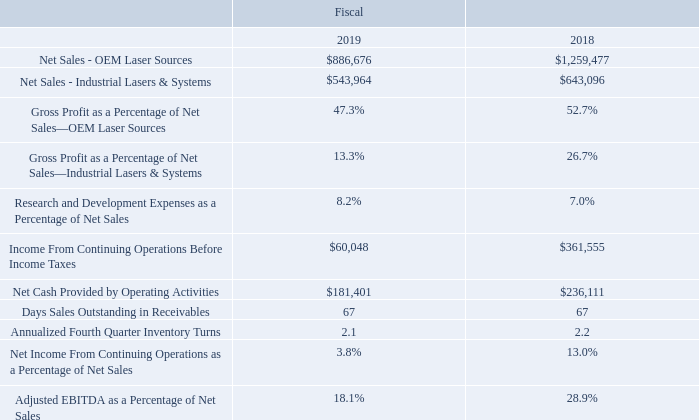KEY PERFORMANCE INDICATORS
Below is a summary of some of the quantitative performance indicators (as defined below) that are evaluated by management to assess our financial performance. Some of the indicators are non-GAAP measures and should not be considered as an alternative to any other measure for determining operating performance or liquidity that is calculated in accordance with generally accepted accounting principles.
Definitions and analysis of these performance indicators are as follows:
Net Sales Net sales include sales of lasers, laser systems, related accessories and service. Net sales for fiscal 2019 decreased 29.6% in our OLS segment and decreased 15.4% in our ILS segment from fiscal 2018. For a description of the reasons for changes in net sales refer to the ‘‘Results of Operations’’ section below.
Gross Profit as a Percentage of Net Sales Gross profit as a percentage of net sales (‘‘gross profit percentage’’) is calculated as gross profit for the period divided by net sales for the period. Gross profit percentage for OLS decreased to 47.3% in fiscal 2019 from 52.7% in fiscal 2018. Gross profit percentage for ILS decreased to 13.3% in fiscal 2019 from 26.7% in fiscal 2018. For a description of the reasons for changes in gross profit refer to the ‘‘Results of Operations’’ section below.
Research and Development as a Percentage of Net Sales Research and development as a percentage of net sales (‘‘R&D percentage’’) is calculated as research and development expense for the period divided by net sales for the period. Management considers R&D percentage to be an important indicator in managing our business as investing in new technologies is a key to future growth. R&D percentage increased to 8.2% in fiscal 2019 from 7.0% in fiscal 2018. For a description of the reasons for changes in R&D spending refer to the ‘‘Results of Operations’’ section below.
Net Cash Provided by Operating Activities Net cash provided by operating activities shown on our Consolidated Statements of Cash Flows primarily represents the excess of cash collected from billings to our customers and other receipts over cash paid to our vendors for expenses and inventory purchases to run our business. We believe that cash flows from operations is an important performance indicator because cash generation over the long term is essential to maintaining a healthy business and providing funds to help fuel growth. For a description of the reasons for changes in Net Cash Provided by Operating Activities refer to the ‘‘Liquidity and Capital Resources’’ section below.
Days Sales Outstanding in Receivables We calculate days sales outstanding (‘‘DSO’’) in receivables as net receivables at the end of the period divided by net sales during the period and then multiplied by the number of days in the period, using 360 days for years. DSO in receivables indicates how well we are managing our collection of receivables, with lower DSO in receivables resulting in higher working capital availability. The more money we have tied up in receivables, the less money we have available for research and development, acquisitions, expansion, marketing and other activities to grow our business. Our DSO in receivables for fiscal 2019 remained unchanged at 67 days as compared to fiscal 2018.
Annualized Fourth Quarter Inventory Turns We calculate annualized fourth quarter inventory turns as cost of sales during the fourth quarter annualized and divided by net inventories at the end of the fourth quarter. This indicates how well we are managing our inventory levels, with higher inventory turns resulting in more working capital availability and a higher return on our investments in inventory. Our annualized fourth quarter inventory turns for fiscal 2019 decreased to 2.1 turns from 2.2 turns in fiscal 2018 primarily as a result of a decrease in demand for sales of our large ELA tools, partially offset by the impact of lower inventories due to restructuring charges.
Adjusted EBITDA as a Percentage of Net Sales We define adjusted EBITDA as operating income adjusted for depreciation, amortization, stock compensation expense, major restructuring costs and certain other non-operating income and expense items, such as costs related to our acquisitions. Key initiatives to reach our goals for EBITDA improvements include utilization of our Asian manufacturing locations, optimizing our supply chain and continued leveraging of our infrastructure.
We utilize a number of different financial measures, both GAAP and non-GAAP, such as adjusted EBITDA as a percentage of net sales, in analyzing and assessing our overall business performance, for making operating decisions and for forecasting and planning future periods. We consider the use of non-GAAP financial measures helpful in assessing our current financial performance and ongoing operations. While we use non-GAAP financial measures as a tool to enhance our understanding of certain aspects of our financial performance, we do not consider these measures to be a substitute for, or superior to, the information provided by GAAP financial measures. We provide adjusted EBITDA in order to enhance investors’ understanding of our ongoing operations. This measure is used by some investors when assessing our performance.
What does the table show? A summary of some of the quantitative performance indicators (as defined below) that are evaluated by management to assess our financial performance. What is the amount of net sales for OEM Laser Sources in 2019? $886,676. In which years are the key performance indicators provided in the table? 2019, 2018. In which year was Research and Development Expenses as a Percentage of Net Sales larger? 8.2%>7.0%
Answer: 2019. What was the change in Annualized Fourth Quarter Inventory Turns in 2019 from 2018? 2.1-2.2
Answer: -0.1. What was the percentage change in Annualized Fourth Quarter Inventory Turns in 2019 from 2018?
Answer scale should be: percent. (2.1-2.2)/2.2
Answer: -4.55. 